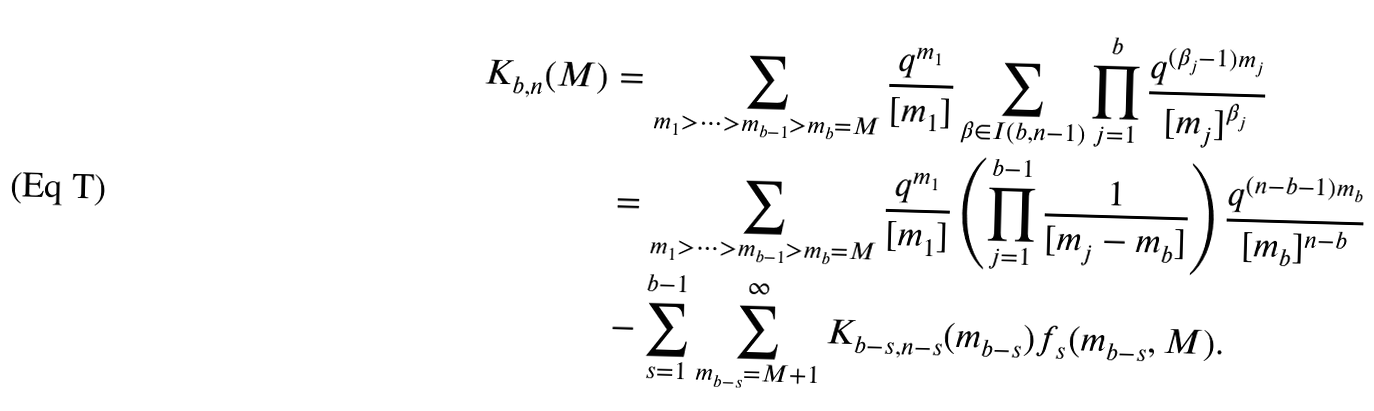Convert formula to latex. <formula><loc_0><loc_0><loc_500><loc_500>K _ { b , n } ( M ) & = \sum _ { m _ { 1 } > \cdots > m _ { b - 1 } > m _ { b } = M } \frac { q ^ { m _ { 1 } } } { [ m _ { 1 } ] } \sum _ { \beta \in I ( b , n - 1 ) } \prod _ { j = 1 } ^ { b } \frac { q ^ { ( \beta _ { j } - 1 ) m _ { j } } } { [ m _ { j } ] ^ { \beta _ { j } } } \\ & = \sum _ { m _ { 1 } > \cdots > m _ { b - 1 } > m _ { b } = M } \frac { q ^ { m _ { 1 } } } { [ m _ { 1 } ] } \left ( \prod _ { j = 1 } ^ { b - 1 } \frac { 1 } { [ m _ { j } - m _ { b } ] } \right ) \frac { q ^ { ( n - b - 1 ) m _ { b } } } { [ m _ { b } ] ^ { n - b } } \\ & - \sum _ { s = 1 } ^ { b - 1 } \sum _ { m _ { b - s } = M + 1 } ^ { \infty } K _ { b - s , n - s } ( m _ { b - s } ) f _ { s } ( m _ { b - s } , M ) .</formula> 